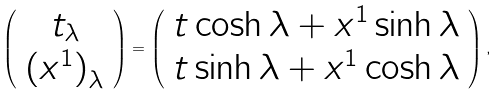<formula> <loc_0><loc_0><loc_500><loc_500>\left ( \begin{array} { c } t _ { \lambda } \\ { ( x ^ { 1 } ) } _ { \lambda } \end{array} \right ) = \left ( \begin{array} { c } t \cosh \lambda + x ^ { 1 } \sinh \lambda \\ t \sinh \lambda + x ^ { 1 } \cosh \lambda \end{array} \right ) ,</formula> 